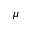Convert formula to latex. <formula><loc_0><loc_0><loc_500><loc_500>\mu</formula> 